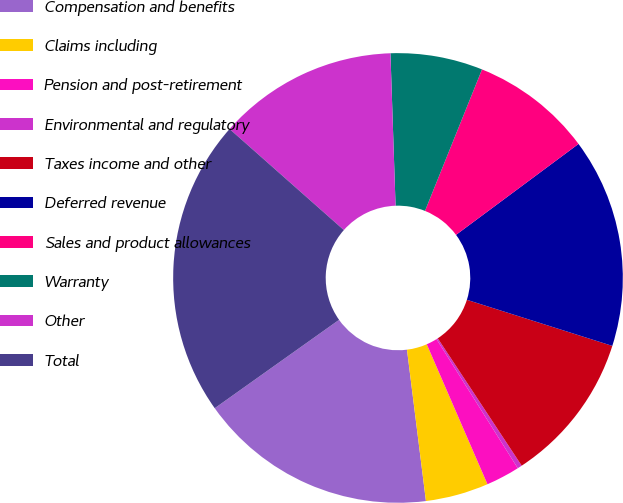<chart> <loc_0><loc_0><loc_500><loc_500><pie_chart><fcel>Compensation and benefits<fcel>Claims including<fcel>Pension and post-retirement<fcel>Environmental and regulatory<fcel>Taxes income and other<fcel>Deferred revenue<fcel>Sales and product allowances<fcel>Warranty<fcel>Other<fcel>Total<nl><fcel>17.15%<fcel>4.53%<fcel>2.43%<fcel>0.33%<fcel>10.84%<fcel>15.05%<fcel>8.74%<fcel>6.63%<fcel>12.94%<fcel>21.36%<nl></chart> 